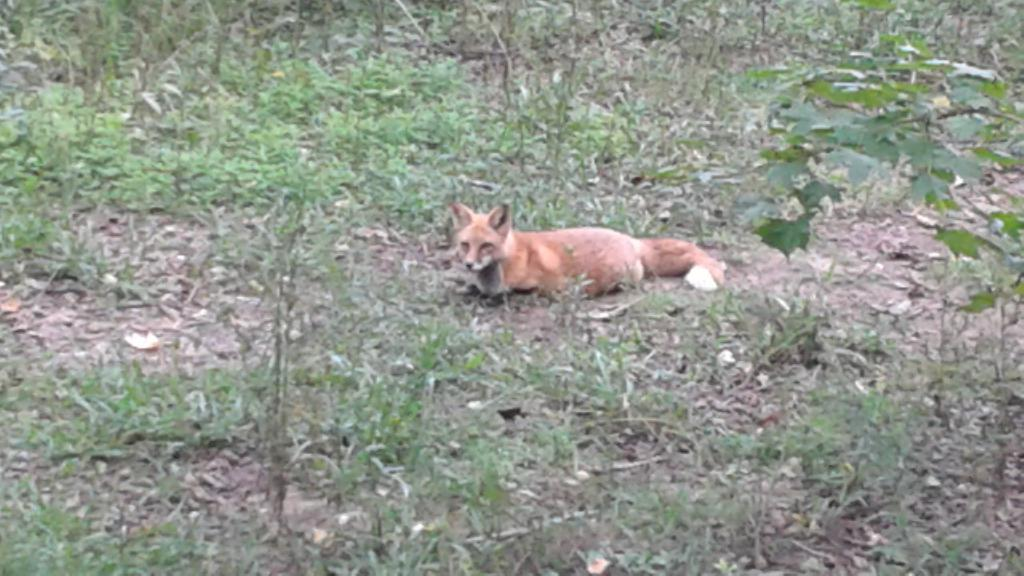What animal can be seen in the picture? There is a fox in the picture. What is the fox doing in the picture? The fox is laying down. What type of vegetation is present at the bottom of the picture? There are leaves and grass at the bottom of the picture. What type of discussion is the fox having with its dad in the picture? There is no discussion or dad present in the picture; it only features a fox laying down. What button is the fox wearing in the picture? There is no button visible on the fox in the picture. 